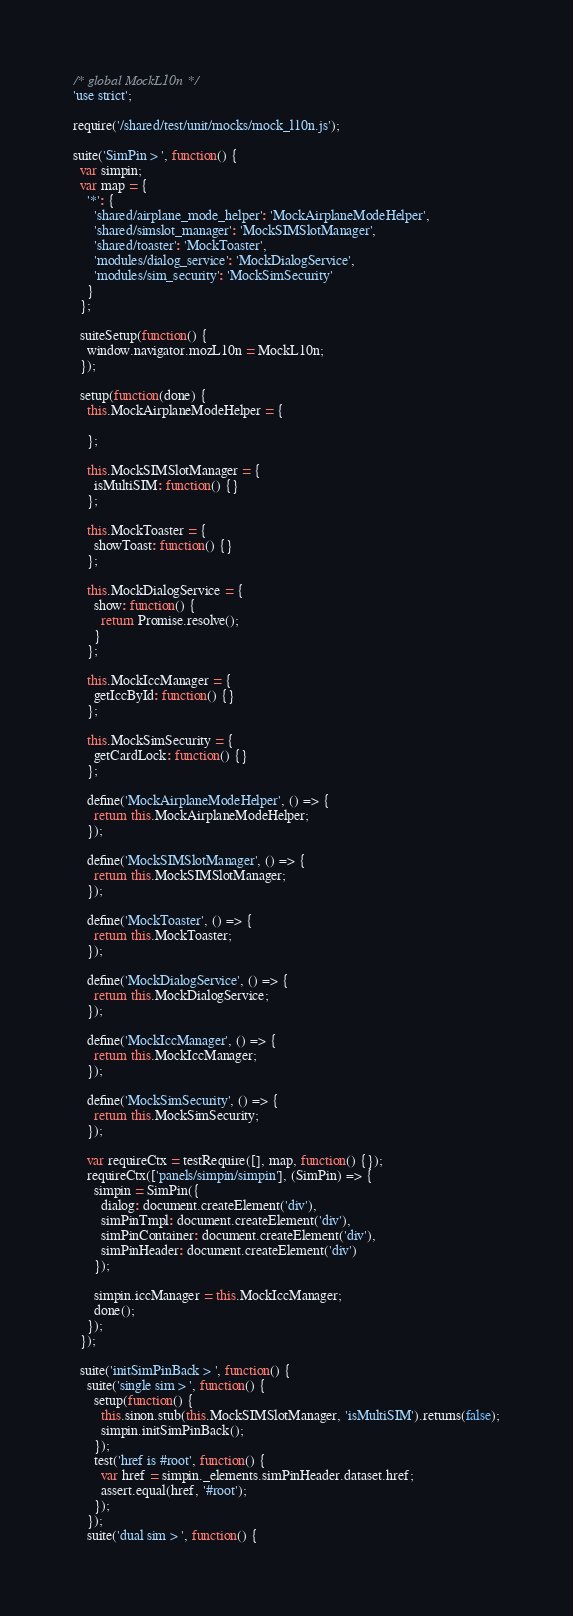Convert code to text. <code><loc_0><loc_0><loc_500><loc_500><_JavaScript_>/* global MockL10n */
'use strict';

require('/shared/test/unit/mocks/mock_l10n.js');

suite('SimPin > ', function() {
  var simpin;
  var map = {
    '*': {
      'shared/airplane_mode_helper': 'MockAirplaneModeHelper',
      'shared/simslot_manager': 'MockSIMSlotManager',
      'shared/toaster': 'MockToaster',
      'modules/dialog_service': 'MockDialogService',
      'modules/sim_security': 'MockSimSecurity'
    }
  };

  suiteSetup(function() {
    window.navigator.mozL10n = MockL10n;
  });

  setup(function(done) {
    this.MockAirplaneModeHelper = {

    };

    this.MockSIMSlotManager = {
      isMultiSIM: function() {}
    };

    this.MockToaster = {
      showToast: function() {}
    };

    this.MockDialogService = {
      show: function() {
        return Promise.resolve();
      }
    };

    this.MockIccManager = {
      getIccById: function() {}
    };

    this.MockSimSecurity = {
      getCardLock: function() {}
    };

    define('MockAirplaneModeHelper', () => {
      return this.MockAirplaneModeHelper;
    });

    define('MockSIMSlotManager', () => {
      return this.MockSIMSlotManager;
    });

    define('MockToaster', () => {
      return this.MockToaster;
    });

    define('MockDialogService', () => {
      return this.MockDialogService;
    });

    define('MockIccManager', () => {
      return this.MockIccManager;
    });

    define('MockSimSecurity', () => {
      return this.MockSimSecurity;
    });

    var requireCtx = testRequire([], map, function() {});
    requireCtx(['panels/simpin/simpin'], (SimPin) => {
      simpin = SimPin({
        dialog: document.createElement('div'),
        simPinTmpl: document.createElement('div'),
        simPinContainer: document.createElement('div'),
        simPinHeader: document.createElement('div')
      });

      simpin.iccManager = this.MockIccManager;
      done();
    });
  });

  suite('initSimPinBack > ', function() {
    suite('single sim > ', function() {
      setup(function() {
        this.sinon.stub(this.MockSIMSlotManager, 'isMultiSIM').returns(false);
        simpin.initSimPinBack();
      });
      test('href is #root', function() {
        var href = simpin._elements.simPinHeader.dataset.href;
        assert.equal(href, '#root');
      });
    });
    suite('dual sim > ', function() {</code> 